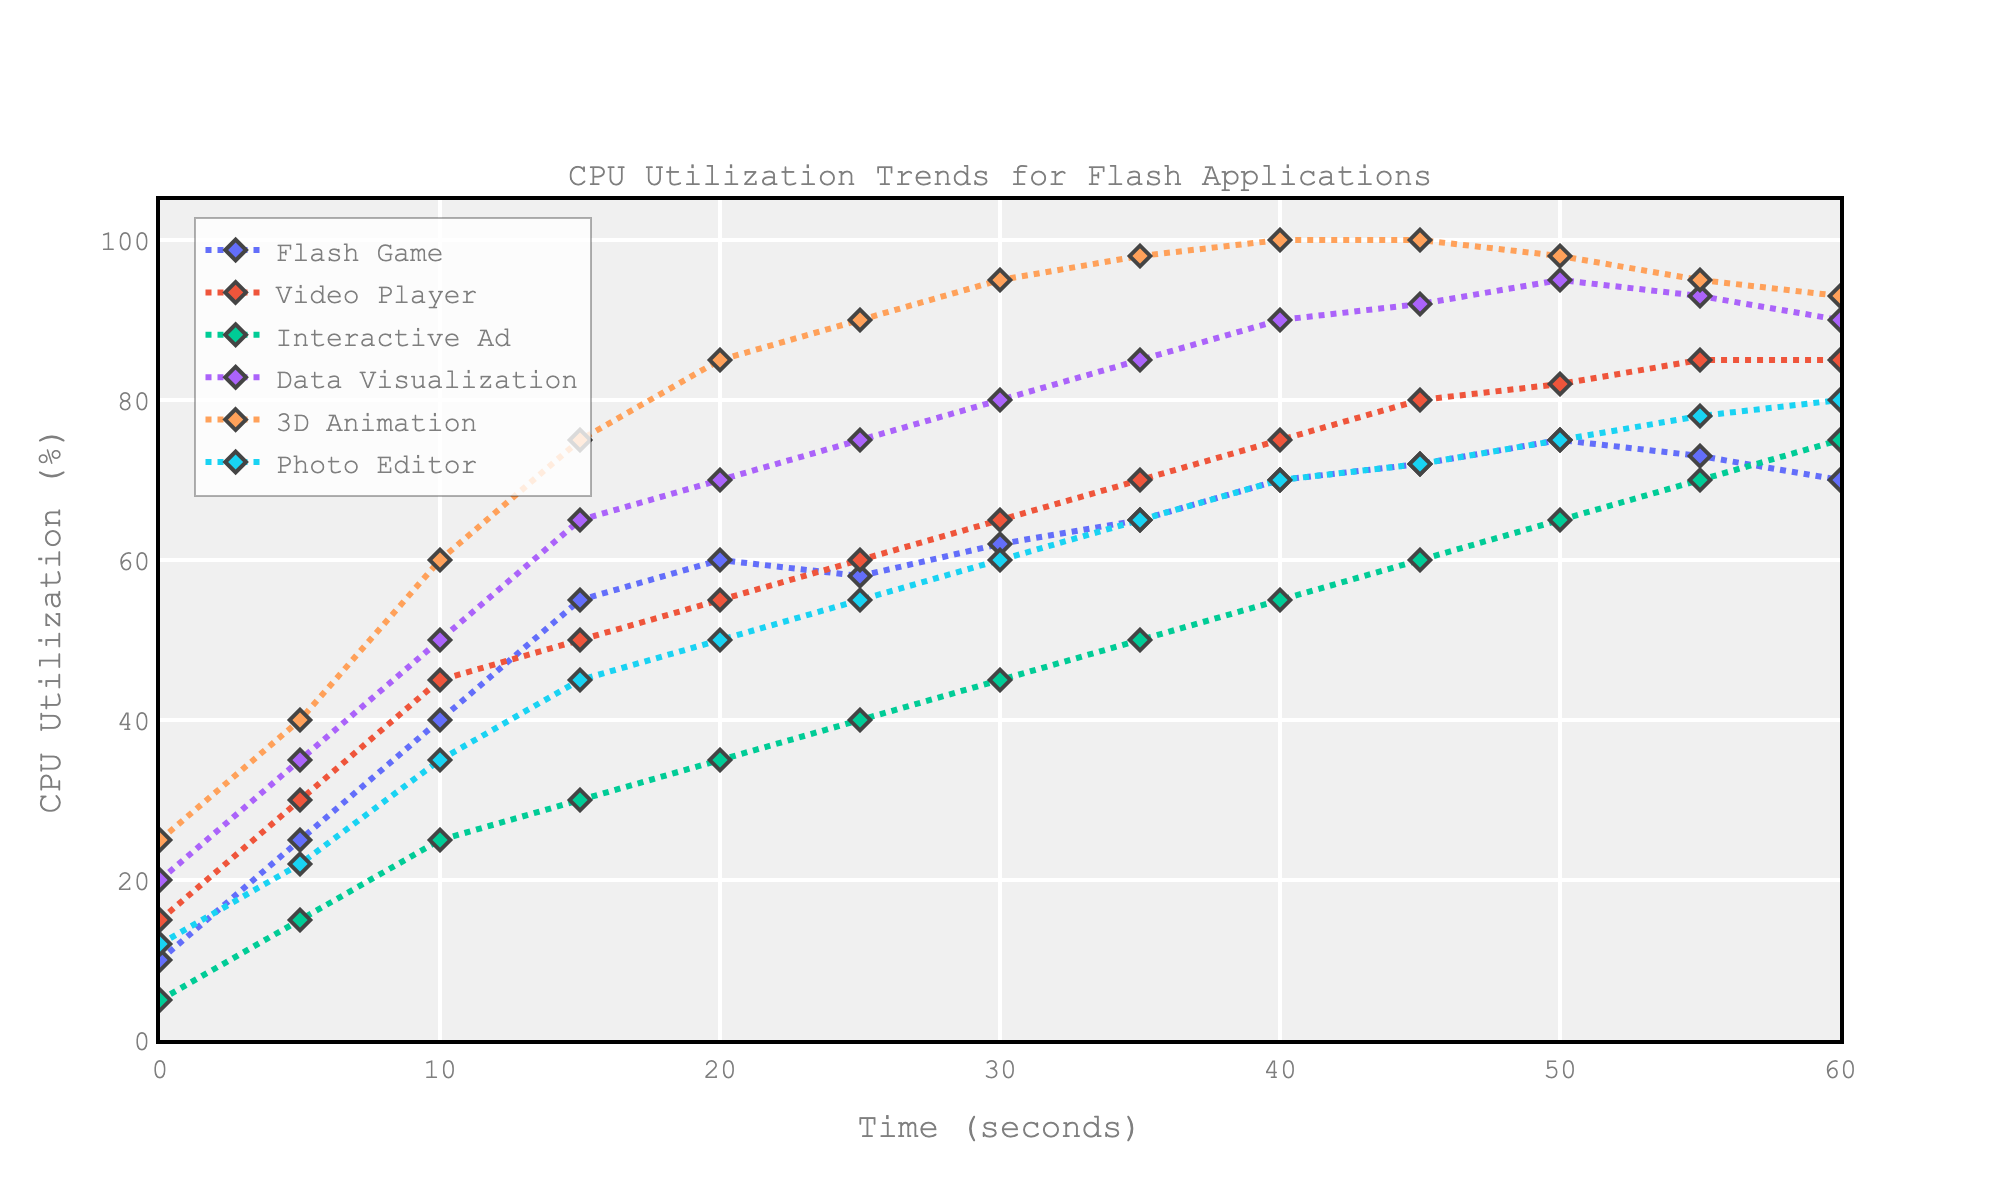What is the CPU utilization for Video Player at the 50-second mark? Refer to the figure and locate the "Video Player" line, then find the point that corresponds to 50 seconds on the X-axis. The Y-coordinate will give the CPU utilization.
Answer: 82 Which application has the highest CPU utilization at any time point? Look for the peak Y-values across all lines on the graph. "3D Animation" reaches the highest utilization at 40s, 45s, and 50s.
Answer: 3D Animation How much does the CPU utilization of Flash Game change from 10 seconds to 60 seconds? Subtract the CPU utilization at 10 seconds (40%) from the utilization at 60 seconds (70%) for Flash Game. So, the change is 70% - 40% = 30%.
Answer: 30% Compare the CPU utilization of Interactive Ad and Photo Editor at the 30-second mark. Which one has higher utilization and by how much? Find the Y-values corresponding to 30 seconds for both applications. Interactive Ad is at 45%, and Photo Editor is at 60%. Photo Editor is higher by 60% - 45% = 15%.
Answer: Photo Editor, by 15% What is the average CPU utilization of Data Visualization from 0 to 60 seconds? Sum up all the Data Visualization percentages (20 + 35 + 50 + 65 + 70 + 75 + 80 + 85 + 90 + 92 + 95 + 93 + 90) = 940. There are 13 points, so the average is 940 / 13 ≈ 72.31%.
Answer: 72.31% How does the CPU utilization trend of Flash Game compare to Interactive Ad over the first 35 seconds? Visually compare the two lines from 0s to 35s. Flash Game starts higher at 10%, rises faster, and overtakes Interactive Ad around 30s. Interactive Ad starts lower at 5% but increases steadily. Flash Game reaches higher utilization quicker.
Answer: Flash Game rises faster At what time does Photo Editor first exceed 50% CPU utilization? Track the Photo Editor line to find the first point where the Y-value is over 50%. This occurs at the 45-second mark.
Answer: 45 seconds Which application shows the steepest increase in CPU utilization over any 5-second interval? Look for the line with the steepest slope between any two adjacent points. "3D Animation" jumps from 25% to 40% between 0 and 5s, an increase of 15%. This is the steepest.
Answer: 3D Animation What is the difference in CPU utilization between Video Player and Flash Game at the last measured point (60 seconds)? Locate the CPU utilization values at 60s for both applications. Video Player is at 85%, and Flash Game is at 70%. The difference is 85% - 70% = 15%.
Answer: 15% Between 35 and 45 seconds, does Data Visualization or 3D Animation have a higher average CPU utilization? Calculate the average for Data Visualization (85+90+92)/3 = 89 and 3D Animation (98+100+100)/3 ≈ 99.33%. 3D Animation's average is higher.
Answer: 3D Animation 